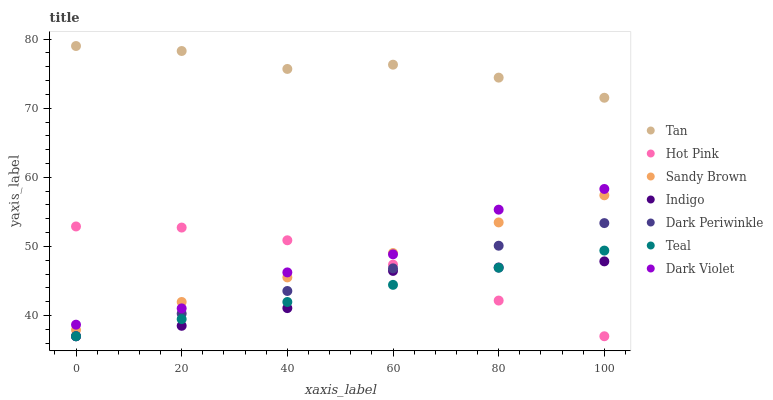Does Indigo have the minimum area under the curve?
Answer yes or no. Yes. Does Tan have the maximum area under the curve?
Answer yes or no. Yes. Does Hot Pink have the minimum area under the curve?
Answer yes or no. No. Does Hot Pink have the maximum area under the curve?
Answer yes or no. No. Is Teal the smoothest?
Answer yes or no. Yes. Is Dark Violet the roughest?
Answer yes or no. Yes. Is Hot Pink the smoothest?
Answer yes or no. No. Is Hot Pink the roughest?
Answer yes or no. No. Does Indigo have the lowest value?
Answer yes or no. Yes. Does Dark Violet have the lowest value?
Answer yes or no. No. Does Tan have the highest value?
Answer yes or no. Yes. Does Hot Pink have the highest value?
Answer yes or no. No. Is Teal less than Dark Violet?
Answer yes or no. Yes. Is Tan greater than Indigo?
Answer yes or no. Yes. Does Dark Violet intersect Sandy Brown?
Answer yes or no. Yes. Is Dark Violet less than Sandy Brown?
Answer yes or no. No. Is Dark Violet greater than Sandy Brown?
Answer yes or no. No. Does Teal intersect Dark Violet?
Answer yes or no. No. 